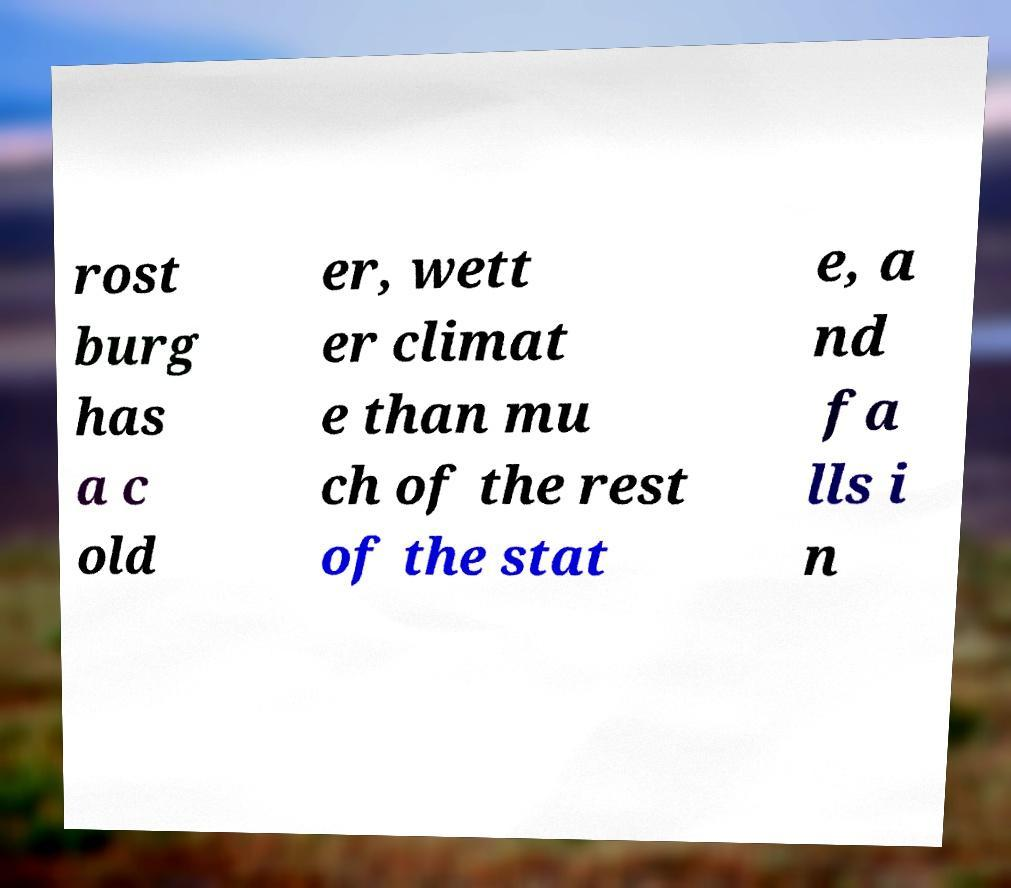Please identify and transcribe the text found in this image. rost burg has a c old er, wett er climat e than mu ch of the rest of the stat e, a nd fa lls i n 